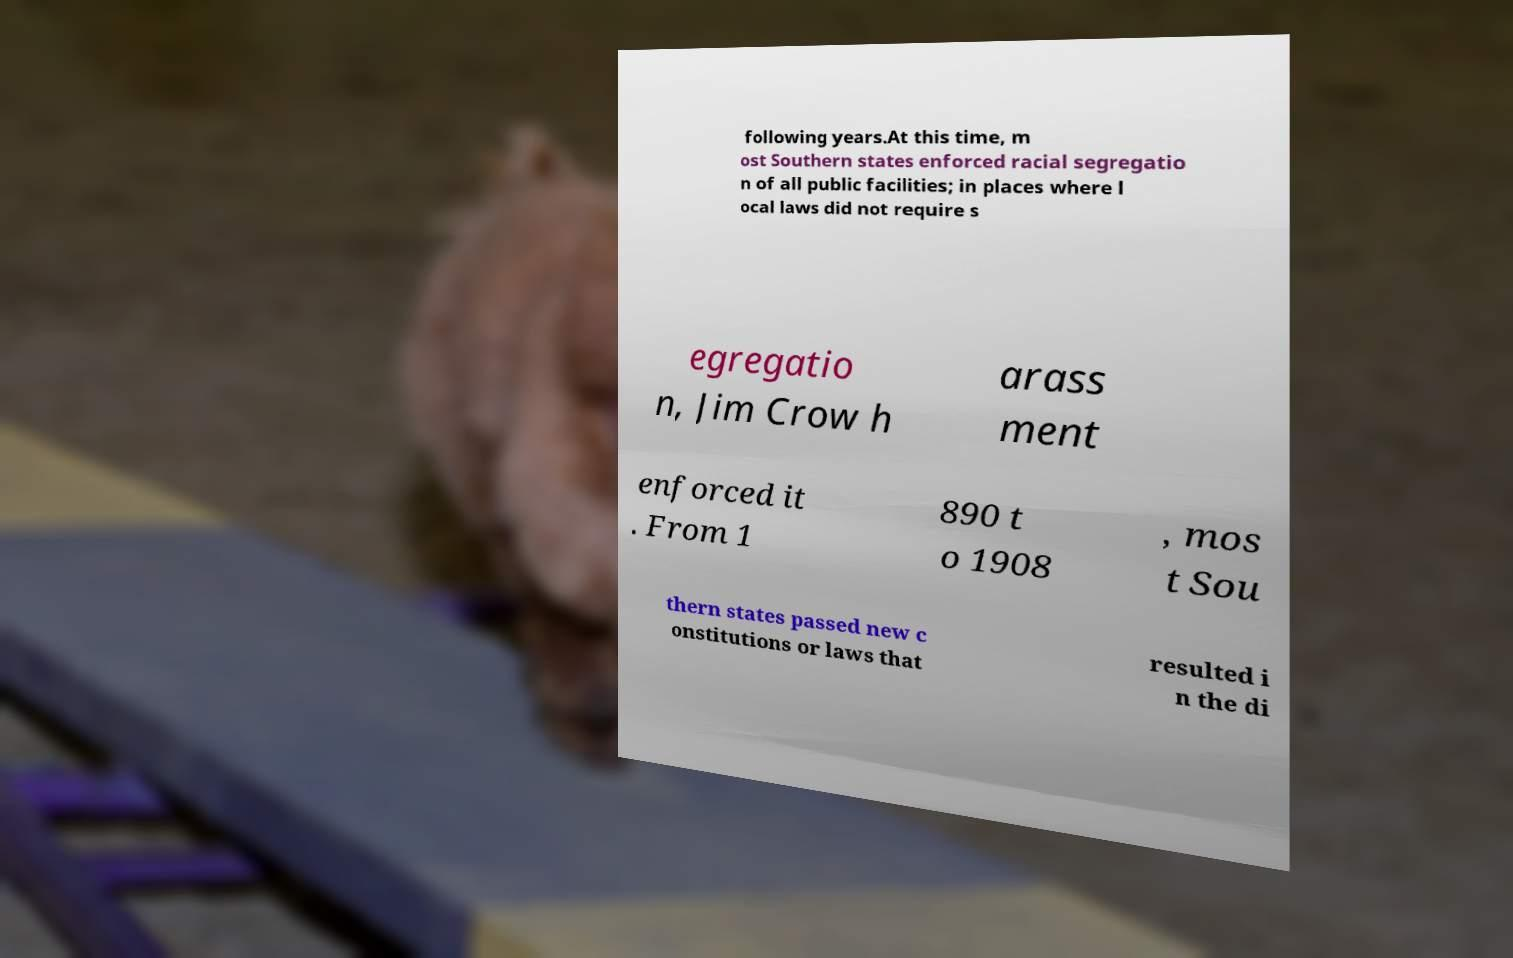Please identify and transcribe the text found in this image. following years.At this time, m ost Southern states enforced racial segregatio n of all public facilities; in places where l ocal laws did not require s egregatio n, Jim Crow h arass ment enforced it . From 1 890 t o 1908 , mos t Sou thern states passed new c onstitutions or laws that resulted i n the di 